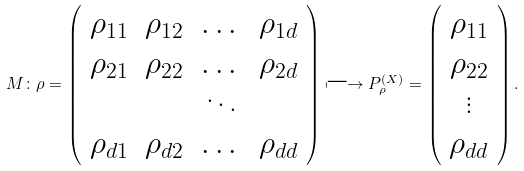Convert formula to latex. <formula><loc_0><loc_0><loc_500><loc_500>M \colon \rho = \left ( \begin{array} { c c c c } \rho _ { 1 1 } & \rho _ { 1 2 } & \dots & \rho _ { 1 d } \\ \rho _ { 2 1 } & \rho _ { 2 2 } & \dots & \rho _ { 2 d } \\ & & \ddots & \\ \rho _ { d 1 } & \rho _ { d 2 } & \dots & \rho _ { d d } \end{array} \right ) \longmapsto P _ { \rho } ^ { ( X ) } = \left ( \begin{array} { c c c c } \rho _ { 1 1 } \\ \rho _ { 2 2 } \\ \vdots \\ \rho _ { d d } \\ \end{array} \right ) .</formula> 